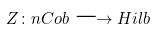Convert formula to latex. <formula><loc_0><loc_0><loc_500><loc_500>Z \colon n C o b \longrightarrow H i l b</formula> 